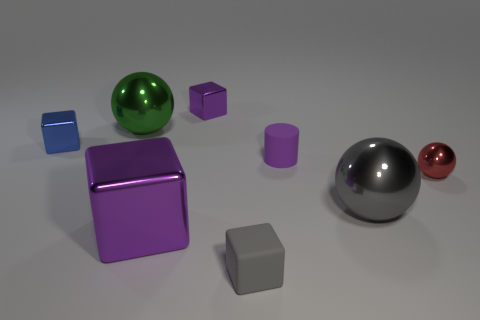How many big things are behind the tiny shiny ball?
Offer a terse response. 1. Does the big cube have the same color as the matte block?
Make the answer very short. No. What shape is the big green thing that is the same material as the red object?
Make the answer very short. Sphere. There is a tiny metallic object that is to the left of the green thing; is its shape the same as the big purple thing?
Your answer should be compact. Yes. How many green things are either large balls or tiny things?
Give a very brief answer. 1. Is the number of purple metallic cubes on the left side of the large gray metal sphere the same as the number of red metallic spheres on the left side of the big purple object?
Provide a succinct answer. No. What color is the small metallic thing that is left of the shiny cube right of the purple metallic object that is in front of the red metal object?
Your answer should be very brief. Blue. Is there any other thing of the same color as the matte cylinder?
Keep it short and to the point. Yes. What is the shape of the big metallic thing that is the same color as the matte cylinder?
Ensure brevity in your answer.  Cube. How big is the purple metal cube that is behind the small blue metallic cube?
Keep it short and to the point. Small. 